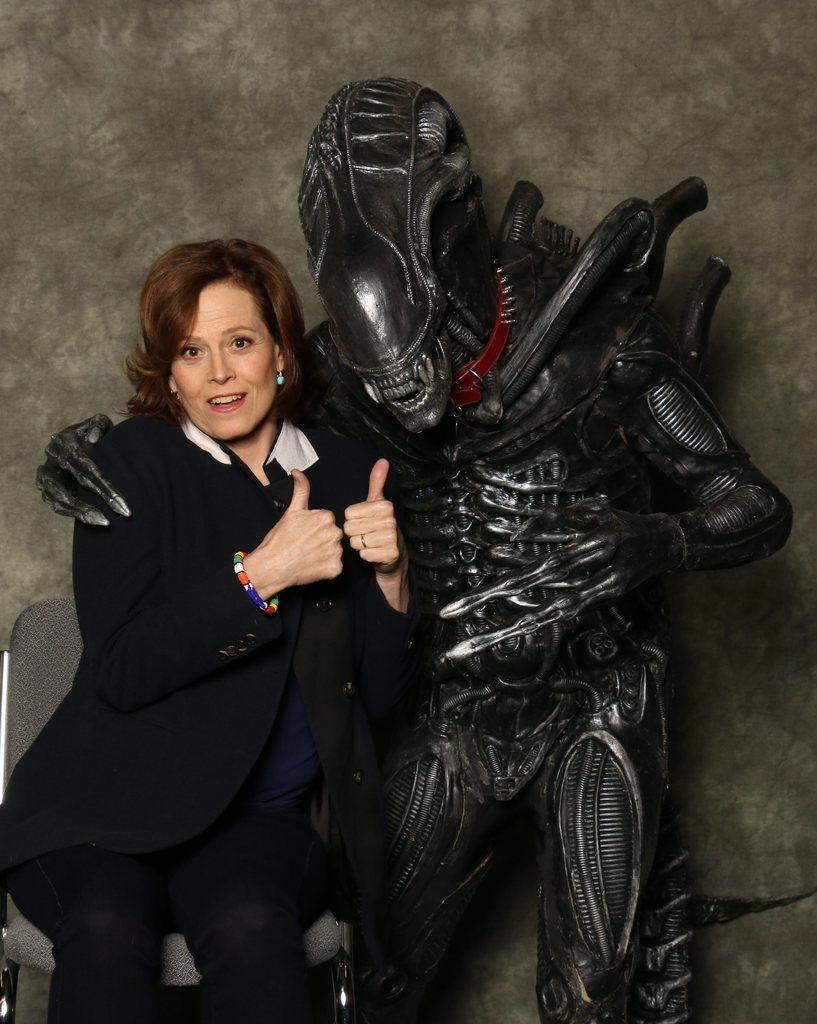Who is the main subject in the image? There is a woman in the middle of the image. What is the woman doing with her hands? The woman is keeping her thumbs up. What other object or character is present in the image? There is a robot beside the woman. How is the robot interacting with the woman? The robot has its hand on the woman. What can be seen in the background of the image? There is a wall in the background of the image. What type of arch can be seen in the image? There is no arch present in the image. What loss is the woman experiencing in the image? There is no indication of any loss in the image; the woman is keeping her thumbs up, which suggests a positive or celebratory gesture. 